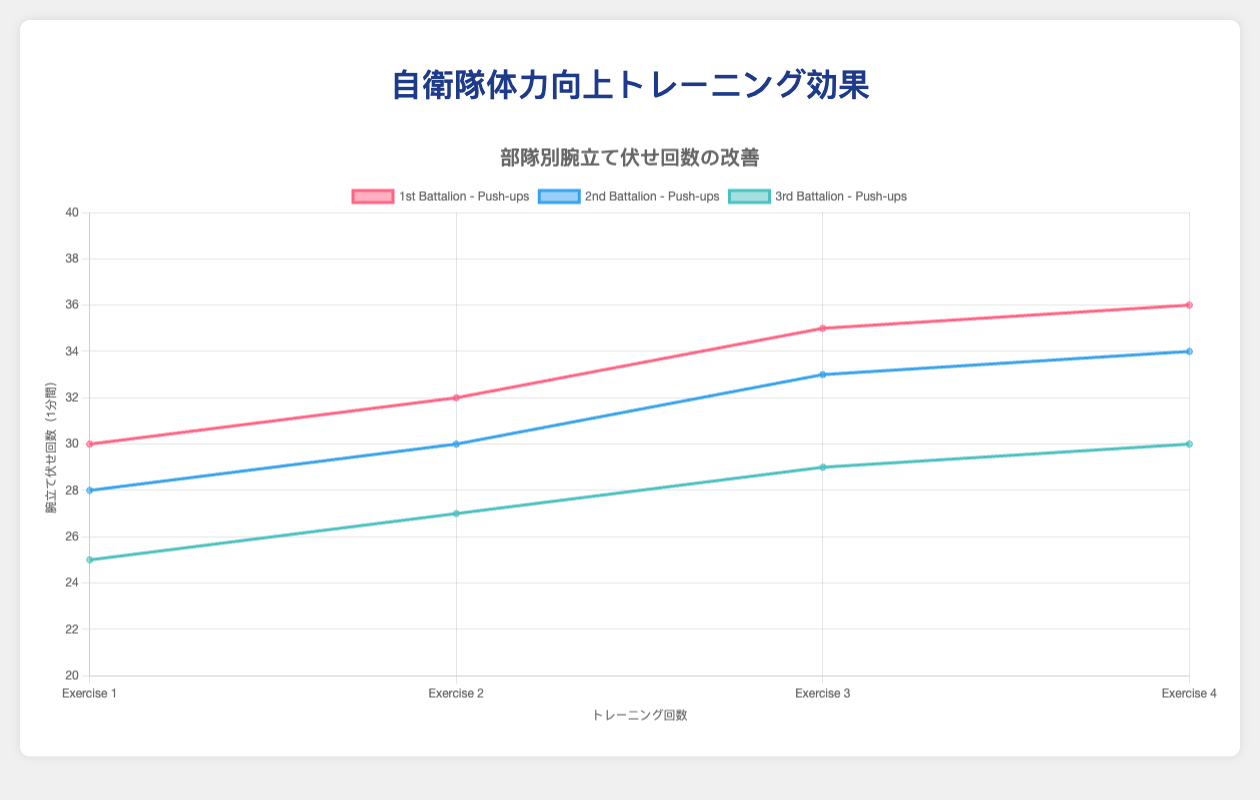What are the push-up improvements for the 1st Battalion from Exercise 1 to Exercise 4? From the figure, the 1st Battalion has the following push-up counts: Exercise 1 (30), Exercise 2 (32), Exercise 3 (35), Exercise 4 (36). Calculate the difference between each consecutive exercise: Exercise 2 - Exercise 1 = 2, Exercise 3 - Exercise 2 = 3, Exercise 4 - Exercise 3 = 1. Thus, the improvements are 2, 3, and 1 push-ups respectively.
Answer: 2, 3, and 1 push-ups Which battalion had the highest number of push-ups at the end of Exercise 4? Look at the last data point for each battalion in the figure: 1st Battalion (36), 2nd Battalion (34), 3rd Battalion (30). The 1st Battalion had the highest number of push-ups with 36.
Answer: 1st Battalion Did the 2nd Battalion continuously improve its push-up performance over the four exercises? For the 2nd Battalion, the push-up counts per exercise are: Exercise 1 (28), Exercise 2 (30), Exercise 3 (33), Exercise 4 (34). Each subsequent amount is higher than the preceding one, indicating continuous improvement.
Answer: Yes What is the average number of push-ups the 1st Battalion performed across all exercises? Sum the push-up counts for the 1st Battalion (30 + 32 + 35 + 36 = 133) and divide by the number of exercises (4). The average is 133 / 4 = 33.25.
Answer: 33.25 Compare the average push-ups of the 1st Battalion to the 3rd Battalion. Which is higher and by how much? Calculate the average for the 3rd Battalion: (25 + 27 + 29 + 30) / 4 = 27.75. The 1st Battalion's average is 33.25. Difference: 33.25 - 27.75 = 5.5. The 1st Battalion's average is higher by 5.5 push-ups.
Answer: 1st Battalion by 5.5 push-ups What color represents the 2nd Battalion's push-up performance data, and which dataset is the tallest at Exercise 2? The 2nd Battalion is represented by blue. At Exercise 2, the tallest dataset is shown by the red color, which corresponds to the 1st Battalion performing 32 push-ups.
Answer: Blue, 1st Battalion Between Exercise 1 and Exercise 4, which battalion showed the greatest overall improvement in push-ups? Calculate the improvements: 1st Battalion from 30 to 36 (6 push-ups), 2nd Battalion from 28 to 34 (6 push-ups), 3rd Battalion from 25 to 30 (5 push-ups). Both 1st and 2nd Battalions showed an improvement of 6 push-ups, greater than the 3rd Battalion's improvement of 5.
Answer: 1st and 2nd Battalions What is the total number of push-ups that the 2nd Battalion completed across all exercises? Sum the push-up counts for the 2nd Battalion: 28 + 30 + 33 + 34 = 125.
Answer: 125 During which exercise did the 3rd Battalion show the greatest increase in push-ups compared to its previous exercise? Calculate the differences for the 3rd Battalion: Exercise 2 - Exercise 1 = 27 - 25 = 2, Exercise 3 - Exercise 2 = 29 - 27 = 2, Exercise 4 - Exercise 3 = 30 - 29 = 1. The greatest increase was 2 push-ups, observed between Exercise 1 and Exercise 2, and likewise between Exercise 2 and Exercise 3.
Answer: Exercise 2 and Exercise 3 (2 push-ups) 